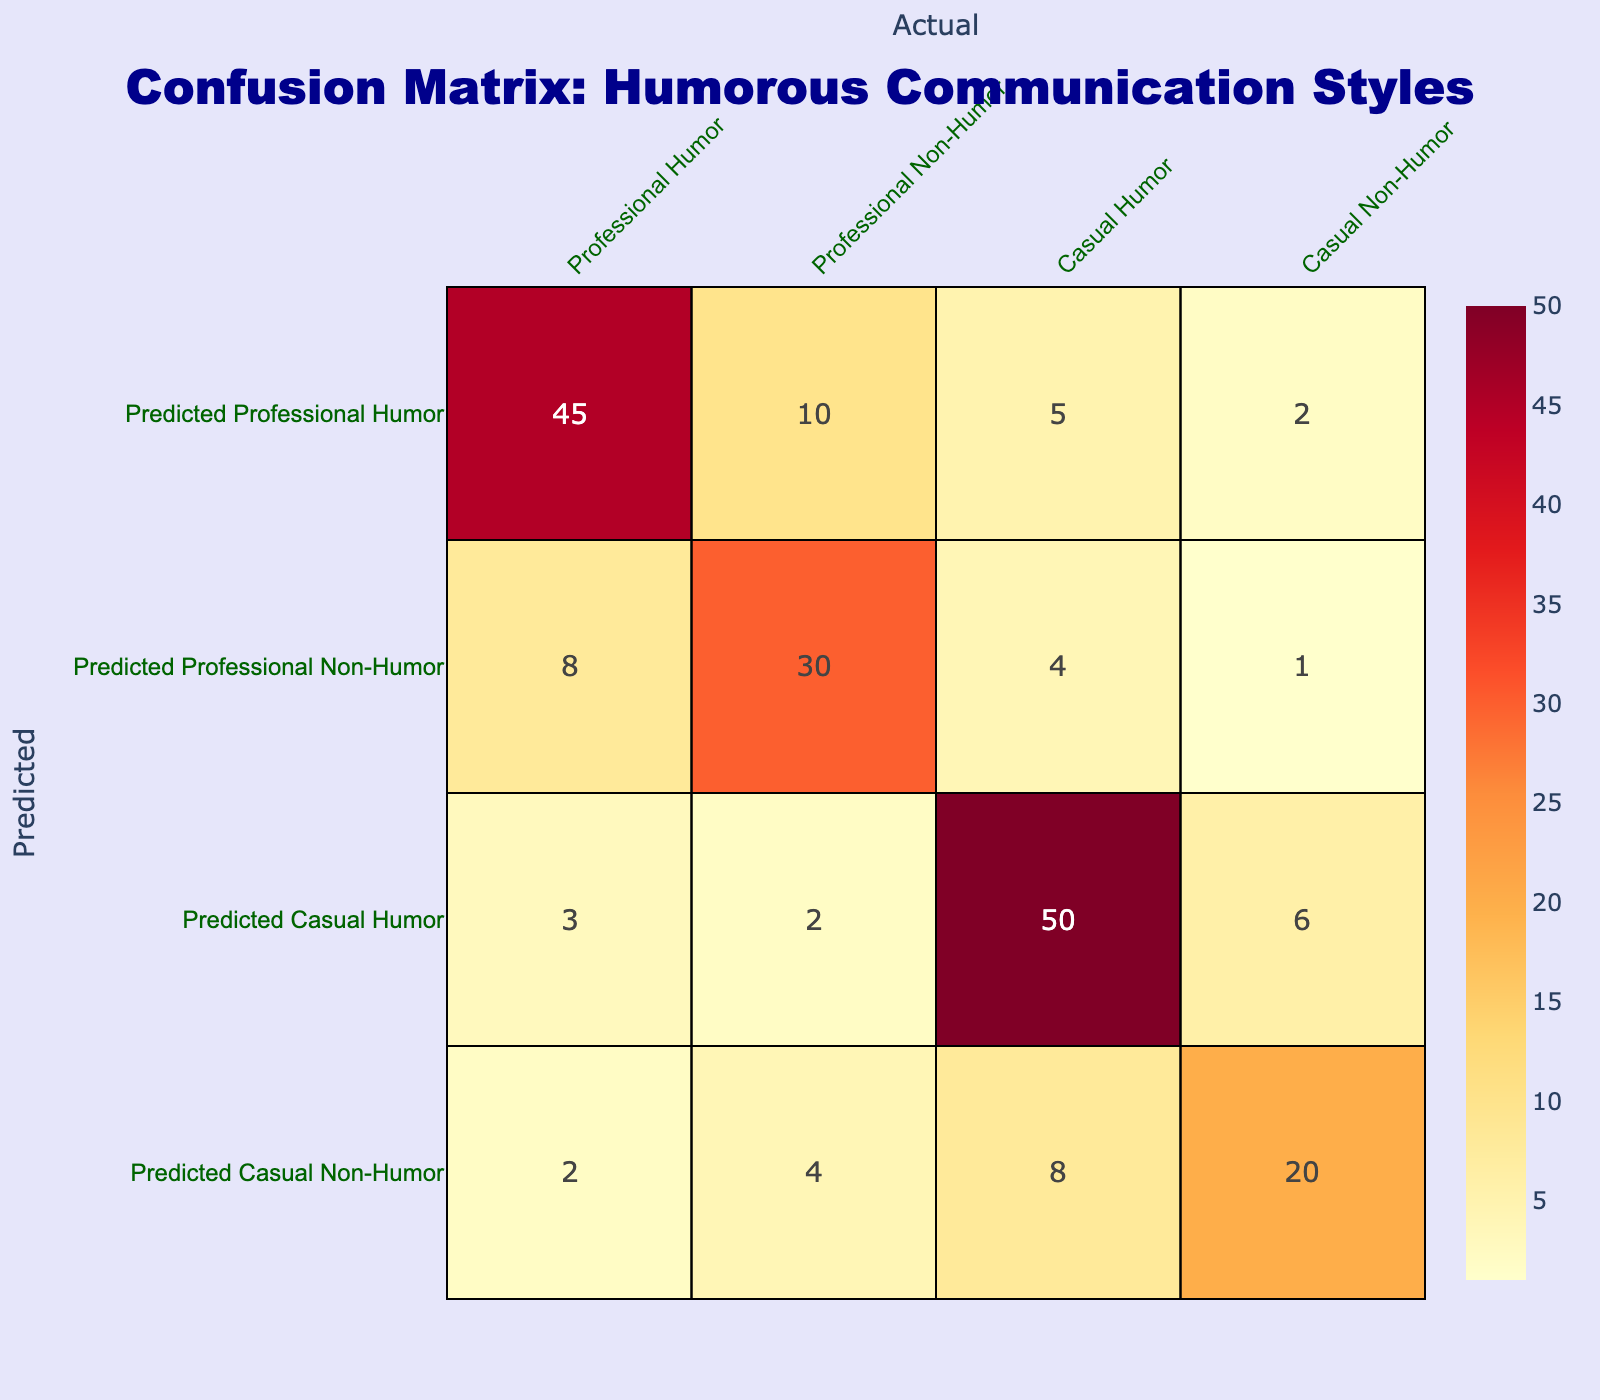What is the total count for predicted Professional Non-Humor? To find the total count for predicted Professional Non-Humor, we look at the values in the corresponding row. Adding them together: 8 (Predicted Professional Non-Humor, Professional Humor) + 30 (Predicted Professional Non-Humor, Professional Non-Humor) + 4 (Predicted Professional Non-Humor, Casual Humor) + 1 (Predicted Professional Non-Humor, Casual Non-Humor) gives us a total of 43.
Answer: 43 What percentage of Casual Humor was correctly predicted? To calculate the percentage of Casual Humor that was correctly predicted, we take the value for Predicted Casual Humor (50) and divide it by the total actual Casual Humor counts (50 + 6 = 56). Thus, the calculation is (50/56) * 100 = 89.29%.
Answer: 89.29% Is there more Professional Humor predicted compared to Casual Non-Humor? For this question, we compare the values from the table: Predicted Professional Humor is 45, and Predicted Casual Non-Humor is 20. Since 45 is greater than 20, we can conclude that more Professional Humor was predicted.
Answer: Yes What is the total value of all predictions for Casual settings? To find the total predictions for Casual settings, we need to sum the values from the corresponding columns: Casual Humor (50) + Casual Non-Humor (6) = 56.
Answer: 56 What is the difference between the predicted and actual counts for Professional Humor? To find the difference, we need to subtract the total actual Professional Humor count from the predicted count. The total actual Professional Humor count is 45 + 8 + 3 + 2 = 58. The predicted Professional Humor count is 45. Therefore, the difference is 58 - 45 = 13.
Answer: 13 In which setting is the misclassification rate higher, Professional or Casual? First, we determine the misclassifications for both settings. For Professional, misclassifications are (10 + 5 + 2 + 8 + 4 + 1) = 30. For Casual, misclassifications are (3 + 2 + 6 + 8) = 19. Since 30 is greater than 19, the misclassification rate is higher in Professional settings.
Answer: Professional What is the overall total for each humor type that was predicted? The overall totals for each humor type are calculated by adding the respective predicted values. For Professional Humor: 45 + 10 = 55. For Professional Non-Humor: 8 + 30 = 38. For Casual Humor: 3 + 2 + 50 + 6 = 61. For Casual Non-Humor: 2 + 4 + 8 + 20 = 34.
Answer: Professional Humor: 55, Professional Non-Humor: 38, Casual Humor: 61, Casual Non-Humor: 34 How many instances of predicted Professional Non-Humor were actually Casual Humor? Referring to the table, the value at the intersection of Predicted Professional Non-Humor and Casual Humor is 4. Thus, there are 4 instances.
Answer: 4 What is the ratio of correctly predicted Casual Non-Humor to total predictions for Casual settings? The correctly predicted Casual Non-Humor is 20, while the total predictions for Casual settings is 56 (from the earlier question's total). Therefore, the ratio is 20/56, which simplifies to 5/14 when divided by 4.
Answer: 5/14 